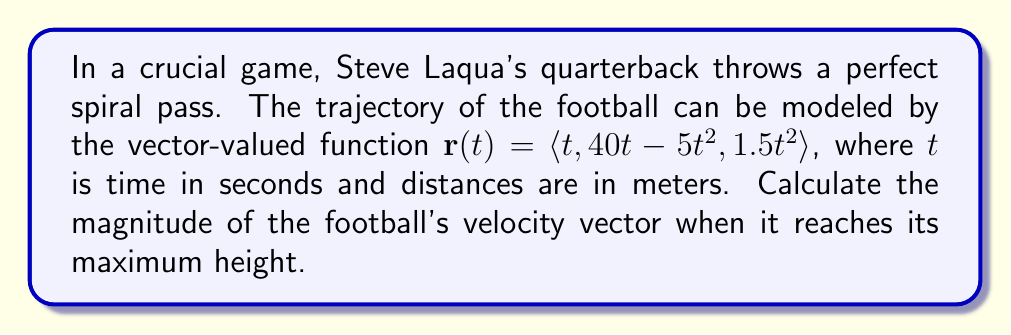Give your solution to this math problem. Let's approach this step-by-step:

1) First, we need to find when the football reaches its maximum height. The y-component of the position vector represents the vertical displacement:

   $y(t) = 40t - 5t^2$

2) To find the maximum height, we differentiate y(t) and set it to zero:

   $\frac{dy}{dt} = 40 - 10t = 0$
   $40 - 10t = 0$
   $t = 4$ seconds

3) Now that we know when the football reaches its maximum height, we need to find the velocity vector at this time. The velocity vector is the derivative of the position vector:

   $\mathbf{v}(t) = \frac{d\mathbf{r}}{dt} = \langle 1, 40 - 10t, 3t \rangle$

4) At $t = 4$ seconds:

   $\mathbf{v}(4) = \langle 1, 40 - 10(4), 3(4) \rangle = \langle 1, 0, 12 \rangle$

5) The magnitude of the velocity vector is given by:

   $\|\mathbf{v}(4)\| = \sqrt{1^2 + 0^2 + 12^2} = \sqrt{145}$

6) Therefore, the magnitude of the velocity vector when the football reaches its maximum height is $\sqrt{145}$ m/s.
Answer: $\sqrt{145}$ m/s 